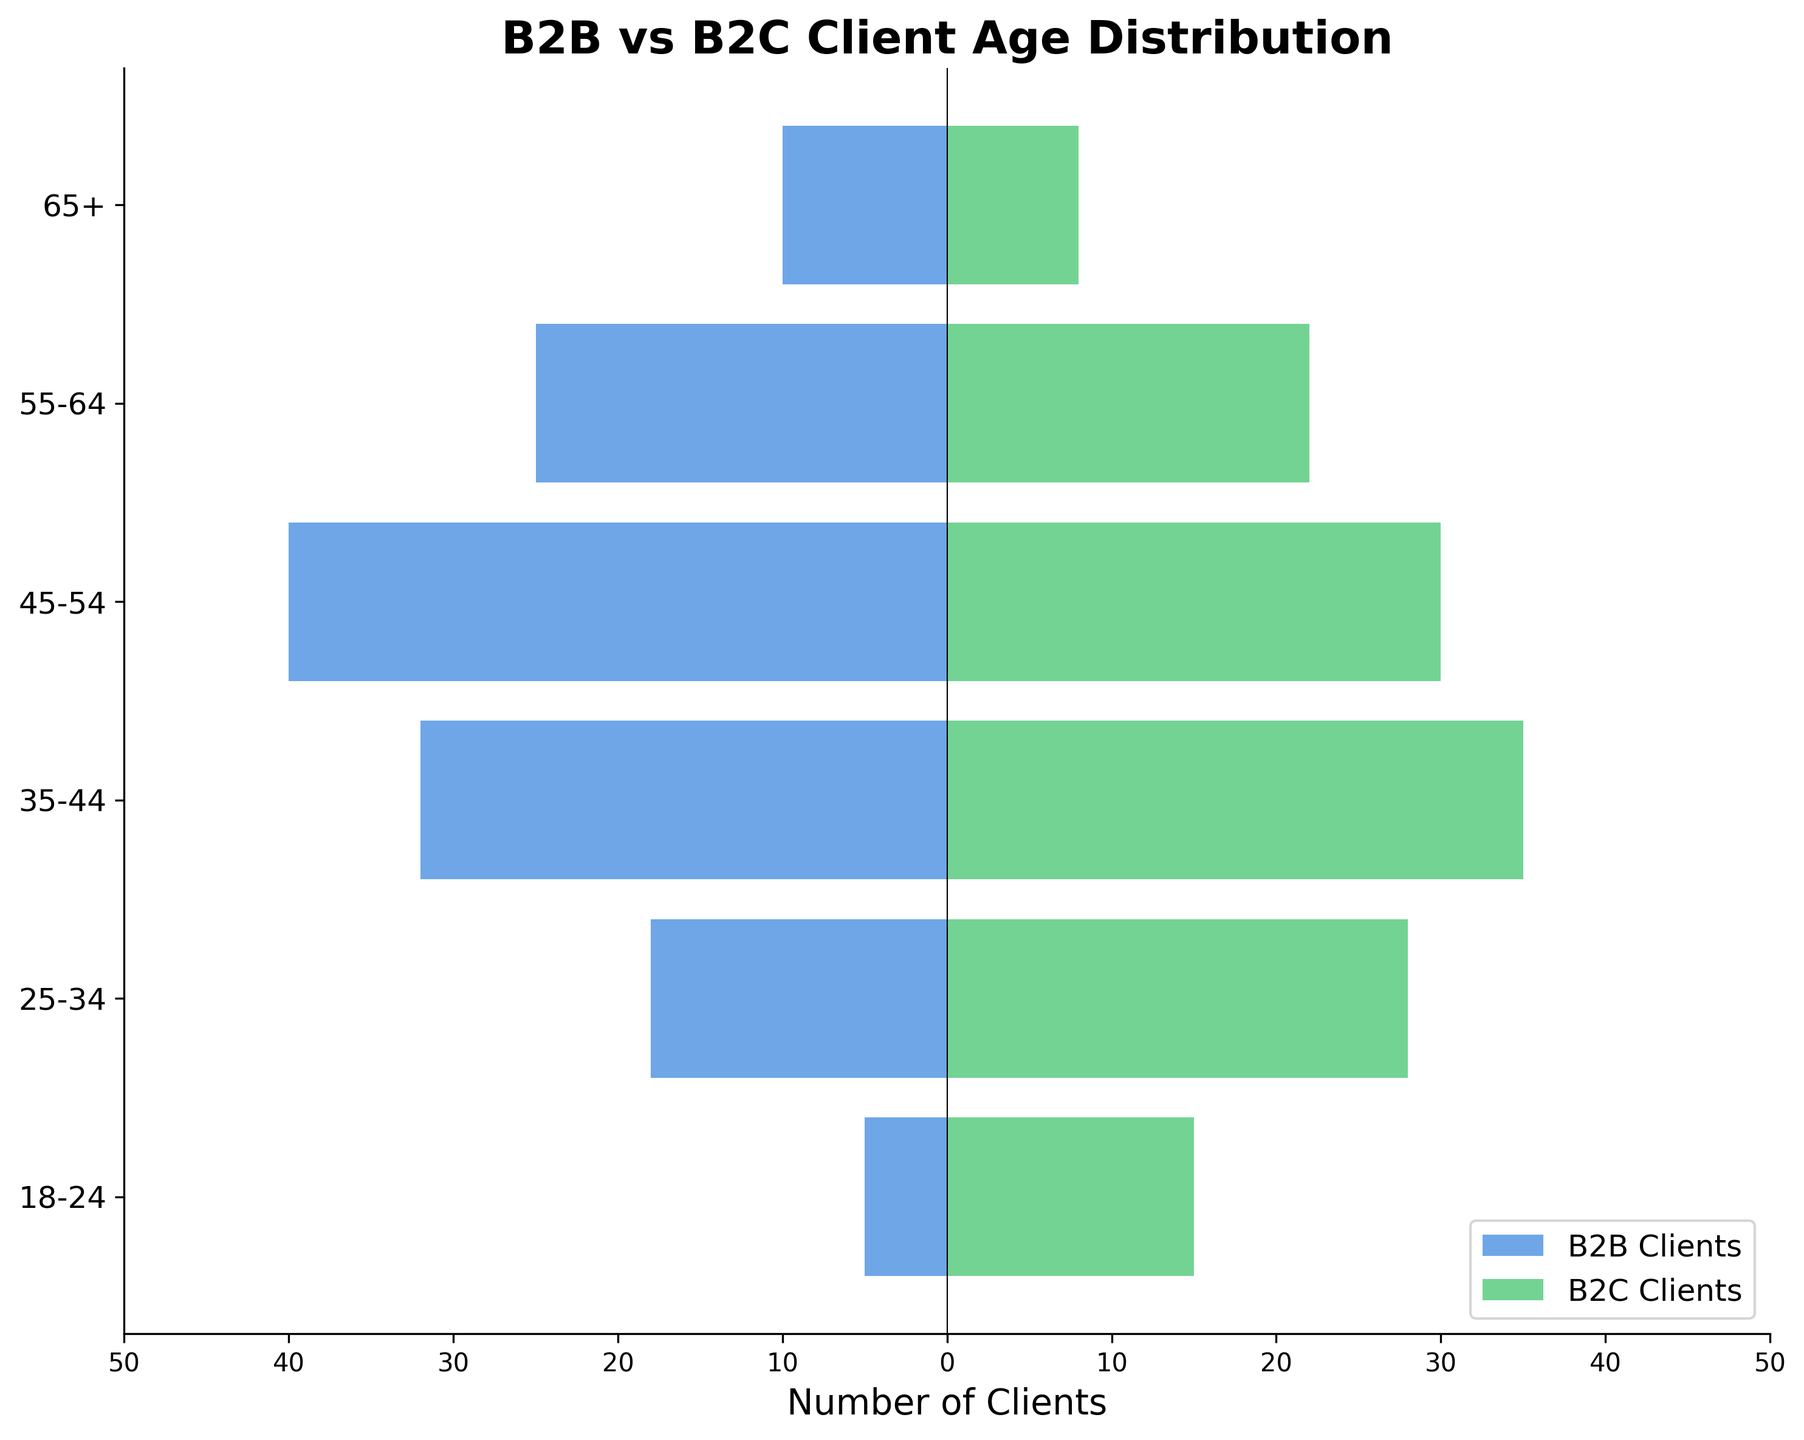What is the title of the figure? The title is always found at the top of the figure and describes what the graph is depicting.
Answer: B2B vs B2C Client Age Distribution What is the range of the x-axis? The x-axis shows the number of clients ranging from a minimum to a maximum value. By observation, the range is from -50 to 50.
Answer: -50 to 50 Which age group has the highest number of B2B clients? The bar with the largest negative value represents the age group with the highest number of B2B clients. The 45-54 age group has the most negative value, -40.
Answer: 45-54 In which age groups do B2C clients outnumber B2B clients? Compare the values of B2C clients (positive bars) and B2B clients (negative bars) for each age group. B2C clients outnumber B2B clients in all age groups.
Answer: All age groups Which age group has the smallest number of B2C clients? The smallest bar on the positive side represents the fewest B2C clients. The 65+ age group has the smallest positive value, 8.
Answer: 65+ What's the sum of B2C clients in the 55-64 and 65+ age groups? Add the B2C clients in both age groups: 22 (55-64) and 8 (65+). 22 + 8 = 30
Answer: 30 